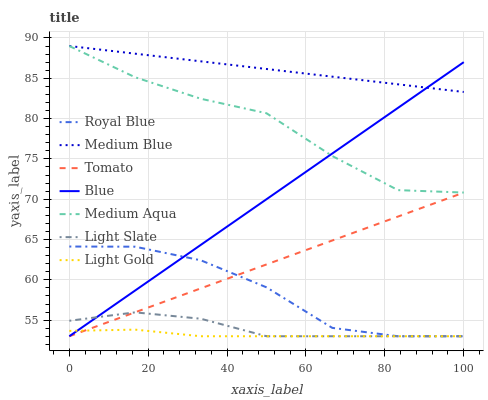Does Light Gold have the minimum area under the curve?
Answer yes or no. Yes. Does Medium Blue have the maximum area under the curve?
Answer yes or no. Yes. Does Blue have the minimum area under the curve?
Answer yes or no. No. Does Blue have the maximum area under the curve?
Answer yes or no. No. Is Tomato the smoothest?
Answer yes or no. Yes. Is Medium Aqua the roughest?
Answer yes or no. Yes. Is Blue the smoothest?
Answer yes or no. No. Is Blue the roughest?
Answer yes or no. No. Does Tomato have the lowest value?
Answer yes or no. Yes. Does Medium Blue have the lowest value?
Answer yes or no. No. Does Medium Aqua have the highest value?
Answer yes or no. Yes. Does Blue have the highest value?
Answer yes or no. No. Is Light Gold less than Medium Blue?
Answer yes or no. Yes. Is Medium Blue greater than Royal Blue?
Answer yes or no. Yes. Does Royal Blue intersect Tomato?
Answer yes or no. Yes. Is Royal Blue less than Tomato?
Answer yes or no. No. Is Royal Blue greater than Tomato?
Answer yes or no. No. Does Light Gold intersect Medium Blue?
Answer yes or no. No. 